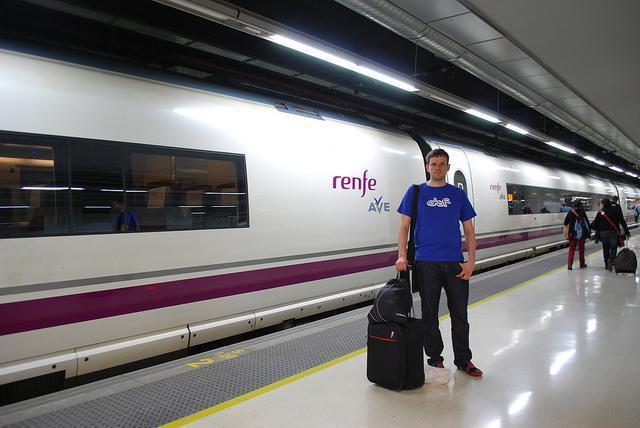How many suitcases are there?
Give a very brief answer. 1. 